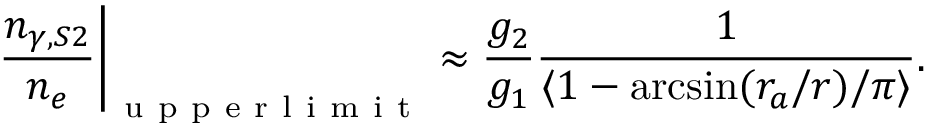Convert formula to latex. <formula><loc_0><loc_0><loc_500><loc_500>\frac { n _ { \gamma , S 2 } } { n _ { e } } \Big | _ { u p p e r l i m i t } \approx \frac { g _ { 2 } } { g _ { 1 } } \frac { 1 } { \langle 1 - \arcsin ( r _ { a } / r ) / \pi \rangle } .</formula> 